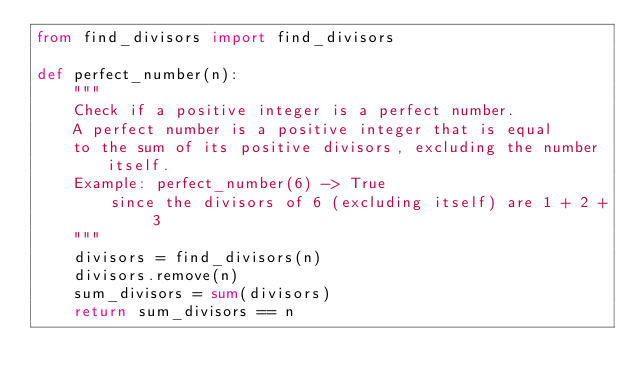Convert code to text. <code><loc_0><loc_0><loc_500><loc_500><_Python_>from find_divisors import find_divisors

def perfect_number(n):
    """
    Check if a positive integer is a perfect number.
    A perfect number is a positive integer that is equal 
    to the sum of its positive divisors, excluding the number itself.
    Example: perfect_number(6) -> True
        since the divisors of 6 (excluding itself) are 1 + 2 + 3
    """
    divisors = find_divisors(n)
    divisors.remove(n)
    sum_divisors = sum(divisors)
    return sum_divisors == n
</code> 